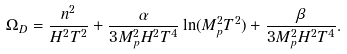<formula> <loc_0><loc_0><loc_500><loc_500>\Omega _ { D } = \frac { n ^ { 2 } } { H ^ { 2 } T ^ { 2 } } + \frac { \alpha } { 3 M _ { p } ^ { 2 } H ^ { 2 } T ^ { 4 } } \ln ( M _ { p } ^ { 2 } T ^ { 2 } ) + \frac { \beta } { 3 M _ { p } ^ { 2 } H ^ { 2 } T ^ { 4 } } .</formula> 